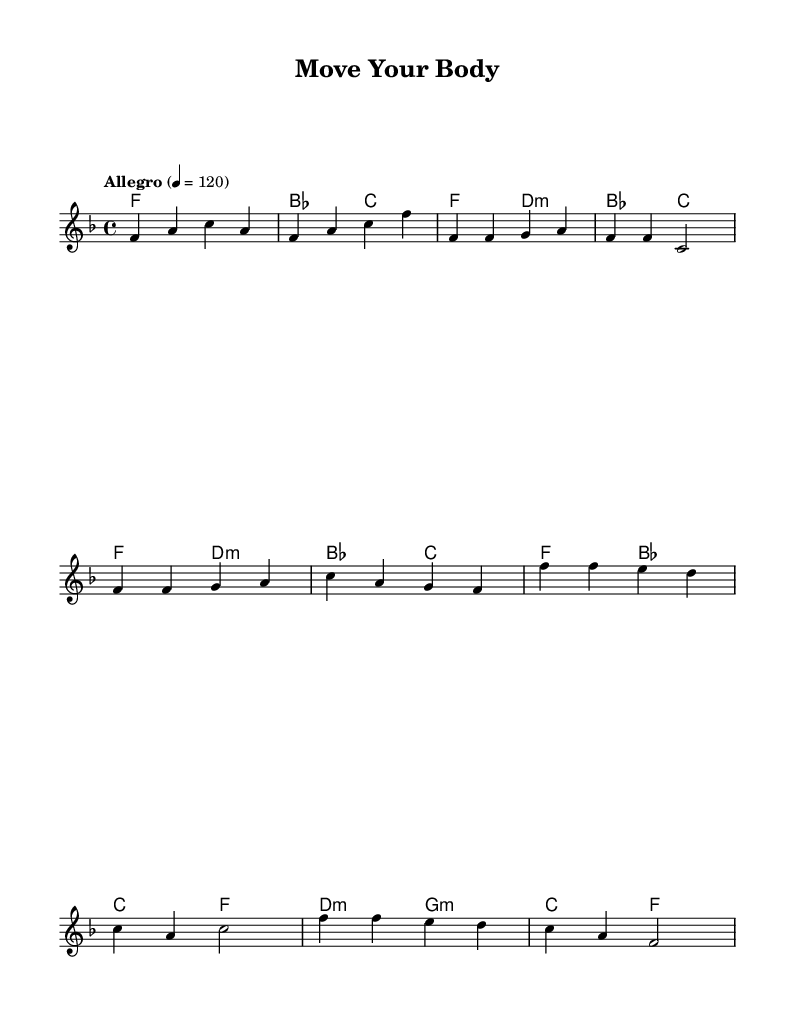What is the key signature of this music? The key signature is shown at the beginning of the staff and indicates F major, which contains one flat (B flat).
Answer: F major What is the time signature of this piece? The time signature is displayed at the beginning of the score, indicating there are four beats per measure (4/4).
Answer: 4/4 What is the tempo marking indicated in the music? The tempo marking is found above the music and shows "Allegro" with a tempo of 120 beats per minute.
Answer: Allegro, 120 How many measures are there in the verse section? By counting the measures in the verse section, which contains two repeated phrases, there are a total of four measures.
Answer: Four What kind of lifestyle does this song celebrate? The words and music emphasize an active and healthy lifestyle, suggesting movement and vitality.
Answer: Active lifestyle Which chord is played at the beginning of the piece? The first chord indicated in the harmonies is F major, which sets the tonal foundation for the music.
Answer: F major What is the main message conveyed in the chorus? The chorus highlights themes of feeling alive and thriving, reflecting joy and health.
Answer: Joy and health 